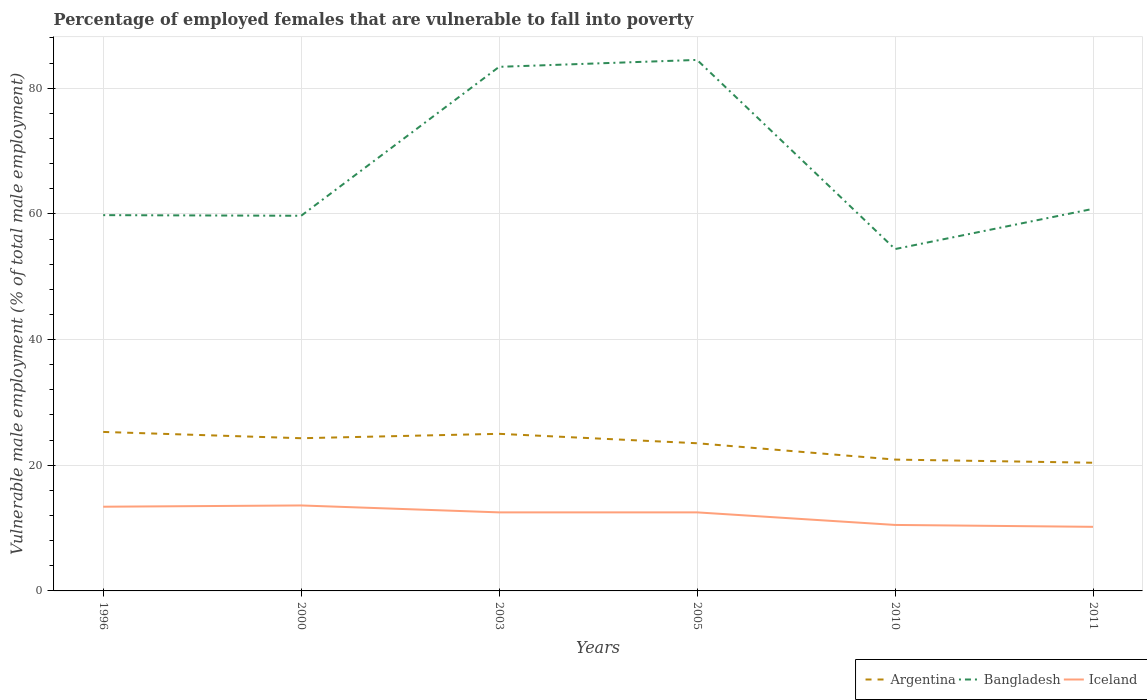Across all years, what is the maximum percentage of employed females who are vulnerable to fall into poverty in Bangladesh?
Your response must be concise. 54.4. In which year was the percentage of employed females who are vulnerable to fall into poverty in Argentina maximum?
Offer a terse response. 2011. What is the total percentage of employed females who are vulnerable to fall into poverty in Iceland in the graph?
Ensure brevity in your answer.  0.9. What is the difference between the highest and the second highest percentage of employed females who are vulnerable to fall into poverty in Iceland?
Give a very brief answer. 3.4. Is the percentage of employed females who are vulnerable to fall into poverty in Bangladesh strictly greater than the percentage of employed females who are vulnerable to fall into poverty in Iceland over the years?
Offer a terse response. No. How many lines are there?
Your answer should be compact. 3. What is the difference between two consecutive major ticks on the Y-axis?
Give a very brief answer. 20. Does the graph contain any zero values?
Give a very brief answer. No. Does the graph contain grids?
Give a very brief answer. Yes. Where does the legend appear in the graph?
Your answer should be very brief. Bottom right. What is the title of the graph?
Keep it short and to the point. Percentage of employed females that are vulnerable to fall into poverty. What is the label or title of the Y-axis?
Offer a terse response. Vulnerable male employment (% of total male employment). What is the Vulnerable male employment (% of total male employment) of Argentina in 1996?
Ensure brevity in your answer.  25.3. What is the Vulnerable male employment (% of total male employment) in Bangladesh in 1996?
Ensure brevity in your answer.  59.8. What is the Vulnerable male employment (% of total male employment) in Iceland in 1996?
Provide a short and direct response. 13.4. What is the Vulnerable male employment (% of total male employment) of Argentina in 2000?
Ensure brevity in your answer.  24.3. What is the Vulnerable male employment (% of total male employment) of Bangladesh in 2000?
Make the answer very short. 59.7. What is the Vulnerable male employment (% of total male employment) of Iceland in 2000?
Keep it short and to the point. 13.6. What is the Vulnerable male employment (% of total male employment) of Bangladesh in 2003?
Your answer should be compact. 83.4. What is the Vulnerable male employment (% of total male employment) of Argentina in 2005?
Make the answer very short. 23.5. What is the Vulnerable male employment (% of total male employment) of Bangladesh in 2005?
Offer a very short reply. 84.5. What is the Vulnerable male employment (% of total male employment) of Iceland in 2005?
Offer a terse response. 12.5. What is the Vulnerable male employment (% of total male employment) of Argentina in 2010?
Your response must be concise. 20.9. What is the Vulnerable male employment (% of total male employment) of Bangladesh in 2010?
Your response must be concise. 54.4. What is the Vulnerable male employment (% of total male employment) of Argentina in 2011?
Give a very brief answer. 20.4. What is the Vulnerable male employment (% of total male employment) in Bangladesh in 2011?
Provide a short and direct response. 60.8. What is the Vulnerable male employment (% of total male employment) of Iceland in 2011?
Your response must be concise. 10.2. Across all years, what is the maximum Vulnerable male employment (% of total male employment) in Argentina?
Keep it short and to the point. 25.3. Across all years, what is the maximum Vulnerable male employment (% of total male employment) of Bangladesh?
Your response must be concise. 84.5. Across all years, what is the maximum Vulnerable male employment (% of total male employment) of Iceland?
Ensure brevity in your answer.  13.6. Across all years, what is the minimum Vulnerable male employment (% of total male employment) in Argentina?
Your answer should be very brief. 20.4. Across all years, what is the minimum Vulnerable male employment (% of total male employment) in Bangladesh?
Ensure brevity in your answer.  54.4. Across all years, what is the minimum Vulnerable male employment (% of total male employment) in Iceland?
Your answer should be very brief. 10.2. What is the total Vulnerable male employment (% of total male employment) in Argentina in the graph?
Your answer should be very brief. 139.4. What is the total Vulnerable male employment (% of total male employment) of Bangladesh in the graph?
Give a very brief answer. 402.6. What is the total Vulnerable male employment (% of total male employment) in Iceland in the graph?
Make the answer very short. 72.7. What is the difference between the Vulnerable male employment (% of total male employment) in Argentina in 1996 and that in 2000?
Keep it short and to the point. 1. What is the difference between the Vulnerable male employment (% of total male employment) of Bangladesh in 1996 and that in 2000?
Ensure brevity in your answer.  0.1. What is the difference between the Vulnerable male employment (% of total male employment) of Argentina in 1996 and that in 2003?
Offer a terse response. 0.3. What is the difference between the Vulnerable male employment (% of total male employment) of Bangladesh in 1996 and that in 2003?
Provide a short and direct response. -23.6. What is the difference between the Vulnerable male employment (% of total male employment) in Bangladesh in 1996 and that in 2005?
Offer a very short reply. -24.7. What is the difference between the Vulnerable male employment (% of total male employment) in Argentina in 2000 and that in 2003?
Offer a terse response. -0.7. What is the difference between the Vulnerable male employment (% of total male employment) in Bangladesh in 2000 and that in 2003?
Your answer should be compact. -23.7. What is the difference between the Vulnerable male employment (% of total male employment) in Iceland in 2000 and that in 2003?
Make the answer very short. 1.1. What is the difference between the Vulnerable male employment (% of total male employment) in Bangladesh in 2000 and that in 2005?
Keep it short and to the point. -24.8. What is the difference between the Vulnerable male employment (% of total male employment) of Argentina in 2000 and that in 2010?
Offer a very short reply. 3.4. What is the difference between the Vulnerable male employment (% of total male employment) of Bangladesh in 2000 and that in 2010?
Your answer should be very brief. 5.3. What is the difference between the Vulnerable male employment (% of total male employment) of Argentina in 2000 and that in 2011?
Keep it short and to the point. 3.9. What is the difference between the Vulnerable male employment (% of total male employment) of Argentina in 2003 and that in 2005?
Your answer should be compact. 1.5. What is the difference between the Vulnerable male employment (% of total male employment) of Bangladesh in 2003 and that in 2005?
Your response must be concise. -1.1. What is the difference between the Vulnerable male employment (% of total male employment) of Iceland in 2003 and that in 2010?
Your answer should be compact. 2. What is the difference between the Vulnerable male employment (% of total male employment) in Bangladesh in 2003 and that in 2011?
Provide a short and direct response. 22.6. What is the difference between the Vulnerable male employment (% of total male employment) of Argentina in 2005 and that in 2010?
Offer a terse response. 2.6. What is the difference between the Vulnerable male employment (% of total male employment) of Bangladesh in 2005 and that in 2010?
Your response must be concise. 30.1. What is the difference between the Vulnerable male employment (% of total male employment) of Bangladesh in 2005 and that in 2011?
Provide a succinct answer. 23.7. What is the difference between the Vulnerable male employment (% of total male employment) in Iceland in 2005 and that in 2011?
Offer a terse response. 2.3. What is the difference between the Vulnerable male employment (% of total male employment) in Iceland in 2010 and that in 2011?
Provide a short and direct response. 0.3. What is the difference between the Vulnerable male employment (% of total male employment) in Argentina in 1996 and the Vulnerable male employment (% of total male employment) in Bangladesh in 2000?
Make the answer very short. -34.4. What is the difference between the Vulnerable male employment (% of total male employment) in Bangladesh in 1996 and the Vulnerable male employment (% of total male employment) in Iceland in 2000?
Offer a terse response. 46.2. What is the difference between the Vulnerable male employment (% of total male employment) in Argentina in 1996 and the Vulnerable male employment (% of total male employment) in Bangladesh in 2003?
Offer a very short reply. -58.1. What is the difference between the Vulnerable male employment (% of total male employment) of Argentina in 1996 and the Vulnerable male employment (% of total male employment) of Iceland in 2003?
Your response must be concise. 12.8. What is the difference between the Vulnerable male employment (% of total male employment) in Bangladesh in 1996 and the Vulnerable male employment (% of total male employment) in Iceland in 2003?
Your response must be concise. 47.3. What is the difference between the Vulnerable male employment (% of total male employment) in Argentina in 1996 and the Vulnerable male employment (% of total male employment) in Bangladesh in 2005?
Make the answer very short. -59.2. What is the difference between the Vulnerable male employment (% of total male employment) in Argentina in 1996 and the Vulnerable male employment (% of total male employment) in Iceland in 2005?
Offer a terse response. 12.8. What is the difference between the Vulnerable male employment (% of total male employment) in Bangladesh in 1996 and the Vulnerable male employment (% of total male employment) in Iceland in 2005?
Your response must be concise. 47.3. What is the difference between the Vulnerable male employment (% of total male employment) of Argentina in 1996 and the Vulnerable male employment (% of total male employment) of Bangladesh in 2010?
Offer a very short reply. -29.1. What is the difference between the Vulnerable male employment (% of total male employment) in Bangladesh in 1996 and the Vulnerable male employment (% of total male employment) in Iceland in 2010?
Provide a succinct answer. 49.3. What is the difference between the Vulnerable male employment (% of total male employment) in Argentina in 1996 and the Vulnerable male employment (% of total male employment) in Bangladesh in 2011?
Provide a succinct answer. -35.5. What is the difference between the Vulnerable male employment (% of total male employment) in Argentina in 1996 and the Vulnerable male employment (% of total male employment) in Iceland in 2011?
Make the answer very short. 15.1. What is the difference between the Vulnerable male employment (% of total male employment) in Bangladesh in 1996 and the Vulnerable male employment (% of total male employment) in Iceland in 2011?
Provide a short and direct response. 49.6. What is the difference between the Vulnerable male employment (% of total male employment) of Argentina in 2000 and the Vulnerable male employment (% of total male employment) of Bangladesh in 2003?
Give a very brief answer. -59.1. What is the difference between the Vulnerable male employment (% of total male employment) in Argentina in 2000 and the Vulnerable male employment (% of total male employment) in Iceland in 2003?
Provide a short and direct response. 11.8. What is the difference between the Vulnerable male employment (% of total male employment) in Bangladesh in 2000 and the Vulnerable male employment (% of total male employment) in Iceland in 2003?
Offer a terse response. 47.2. What is the difference between the Vulnerable male employment (% of total male employment) of Argentina in 2000 and the Vulnerable male employment (% of total male employment) of Bangladesh in 2005?
Give a very brief answer. -60.2. What is the difference between the Vulnerable male employment (% of total male employment) of Argentina in 2000 and the Vulnerable male employment (% of total male employment) of Iceland in 2005?
Provide a short and direct response. 11.8. What is the difference between the Vulnerable male employment (% of total male employment) in Bangladesh in 2000 and the Vulnerable male employment (% of total male employment) in Iceland in 2005?
Offer a very short reply. 47.2. What is the difference between the Vulnerable male employment (% of total male employment) in Argentina in 2000 and the Vulnerable male employment (% of total male employment) in Bangladesh in 2010?
Keep it short and to the point. -30.1. What is the difference between the Vulnerable male employment (% of total male employment) in Bangladesh in 2000 and the Vulnerable male employment (% of total male employment) in Iceland in 2010?
Your answer should be very brief. 49.2. What is the difference between the Vulnerable male employment (% of total male employment) in Argentina in 2000 and the Vulnerable male employment (% of total male employment) in Bangladesh in 2011?
Make the answer very short. -36.5. What is the difference between the Vulnerable male employment (% of total male employment) of Bangladesh in 2000 and the Vulnerable male employment (% of total male employment) of Iceland in 2011?
Give a very brief answer. 49.5. What is the difference between the Vulnerable male employment (% of total male employment) in Argentina in 2003 and the Vulnerable male employment (% of total male employment) in Bangladesh in 2005?
Ensure brevity in your answer.  -59.5. What is the difference between the Vulnerable male employment (% of total male employment) in Argentina in 2003 and the Vulnerable male employment (% of total male employment) in Iceland in 2005?
Give a very brief answer. 12.5. What is the difference between the Vulnerable male employment (% of total male employment) in Bangladesh in 2003 and the Vulnerable male employment (% of total male employment) in Iceland in 2005?
Provide a succinct answer. 70.9. What is the difference between the Vulnerable male employment (% of total male employment) of Argentina in 2003 and the Vulnerable male employment (% of total male employment) of Bangladesh in 2010?
Your response must be concise. -29.4. What is the difference between the Vulnerable male employment (% of total male employment) in Bangladesh in 2003 and the Vulnerable male employment (% of total male employment) in Iceland in 2010?
Your answer should be very brief. 72.9. What is the difference between the Vulnerable male employment (% of total male employment) in Argentina in 2003 and the Vulnerable male employment (% of total male employment) in Bangladesh in 2011?
Your answer should be very brief. -35.8. What is the difference between the Vulnerable male employment (% of total male employment) of Bangladesh in 2003 and the Vulnerable male employment (% of total male employment) of Iceland in 2011?
Offer a very short reply. 73.2. What is the difference between the Vulnerable male employment (% of total male employment) of Argentina in 2005 and the Vulnerable male employment (% of total male employment) of Bangladesh in 2010?
Your answer should be very brief. -30.9. What is the difference between the Vulnerable male employment (% of total male employment) of Argentina in 2005 and the Vulnerable male employment (% of total male employment) of Iceland in 2010?
Ensure brevity in your answer.  13. What is the difference between the Vulnerable male employment (% of total male employment) in Bangladesh in 2005 and the Vulnerable male employment (% of total male employment) in Iceland in 2010?
Keep it short and to the point. 74. What is the difference between the Vulnerable male employment (% of total male employment) of Argentina in 2005 and the Vulnerable male employment (% of total male employment) of Bangladesh in 2011?
Offer a very short reply. -37.3. What is the difference between the Vulnerable male employment (% of total male employment) in Bangladesh in 2005 and the Vulnerable male employment (% of total male employment) in Iceland in 2011?
Give a very brief answer. 74.3. What is the difference between the Vulnerable male employment (% of total male employment) in Argentina in 2010 and the Vulnerable male employment (% of total male employment) in Bangladesh in 2011?
Ensure brevity in your answer.  -39.9. What is the difference between the Vulnerable male employment (% of total male employment) in Bangladesh in 2010 and the Vulnerable male employment (% of total male employment) in Iceland in 2011?
Offer a very short reply. 44.2. What is the average Vulnerable male employment (% of total male employment) in Argentina per year?
Provide a succinct answer. 23.23. What is the average Vulnerable male employment (% of total male employment) in Bangladesh per year?
Ensure brevity in your answer.  67.1. What is the average Vulnerable male employment (% of total male employment) in Iceland per year?
Your response must be concise. 12.12. In the year 1996, what is the difference between the Vulnerable male employment (% of total male employment) in Argentina and Vulnerable male employment (% of total male employment) in Bangladesh?
Your answer should be compact. -34.5. In the year 1996, what is the difference between the Vulnerable male employment (% of total male employment) in Bangladesh and Vulnerable male employment (% of total male employment) in Iceland?
Offer a terse response. 46.4. In the year 2000, what is the difference between the Vulnerable male employment (% of total male employment) in Argentina and Vulnerable male employment (% of total male employment) in Bangladesh?
Keep it short and to the point. -35.4. In the year 2000, what is the difference between the Vulnerable male employment (% of total male employment) in Bangladesh and Vulnerable male employment (% of total male employment) in Iceland?
Your answer should be compact. 46.1. In the year 2003, what is the difference between the Vulnerable male employment (% of total male employment) of Argentina and Vulnerable male employment (% of total male employment) of Bangladesh?
Your answer should be very brief. -58.4. In the year 2003, what is the difference between the Vulnerable male employment (% of total male employment) in Argentina and Vulnerable male employment (% of total male employment) in Iceland?
Make the answer very short. 12.5. In the year 2003, what is the difference between the Vulnerable male employment (% of total male employment) of Bangladesh and Vulnerable male employment (% of total male employment) of Iceland?
Your answer should be compact. 70.9. In the year 2005, what is the difference between the Vulnerable male employment (% of total male employment) of Argentina and Vulnerable male employment (% of total male employment) of Bangladesh?
Your response must be concise. -61. In the year 2005, what is the difference between the Vulnerable male employment (% of total male employment) of Argentina and Vulnerable male employment (% of total male employment) of Iceland?
Your answer should be very brief. 11. In the year 2010, what is the difference between the Vulnerable male employment (% of total male employment) in Argentina and Vulnerable male employment (% of total male employment) in Bangladesh?
Keep it short and to the point. -33.5. In the year 2010, what is the difference between the Vulnerable male employment (% of total male employment) in Argentina and Vulnerable male employment (% of total male employment) in Iceland?
Your response must be concise. 10.4. In the year 2010, what is the difference between the Vulnerable male employment (% of total male employment) in Bangladesh and Vulnerable male employment (% of total male employment) in Iceland?
Give a very brief answer. 43.9. In the year 2011, what is the difference between the Vulnerable male employment (% of total male employment) of Argentina and Vulnerable male employment (% of total male employment) of Bangladesh?
Give a very brief answer. -40.4. In the year 2011, what is the difference between the Vulnerable male employment (% of total male employment) of Argentina and Vulnerable male employment (% of total male employment) of Iceland?
Your answer should be compact. 10.2. In the year 2011, what is the difference between the Vulnerable male employment (% of total male employment) in Bangladesh and Vulnerable male employment (% of total male employment) in Iceland?
Keep it short and to the point. 50.6. What is the ratio of the Vulnerable male employment (% of total male employment) in Argentina in 1996 to that in 2000?
Your answer should be very brief. 1.04. What is the ratio of the Vulnerable male employment (% of total male employment) of Bangladesh in 1996 to that in 2000?
Your answer should be compact. 1. What is the ratio of the Vulnerable male employment (% of total male employment) in Iceland in 1996 to that in 2000?
Provide a short and direct response. 0.99. What is the ratio of the Vulnerable male employment (% of total male employment) in Bangladesh in 1996 to that in 2003?
Provide a succinct answer. 0.72. What is the ratio of the Vulnerable male employment (% of total male employment) of Iceland in 1996 to that in 2003?
Keep it short and to the point. 1.07. What is the ratio of the Vulnerable male employment (% of total male employment) in Argentina in 1996 to that in 2005?
Offer a very short reply. 1.08. What is the ratio of the Vulnerable male employment (% of total male employment) of Bangladesh in 1996 to that in 2005?
Provide a short and direct response. 0.71. What is the ratio of the Vulnerable male employment (% of total male employment) of Iceland in 1996 to that in 2005?
Your answer should be compact. 1.07. What is the ratio of the Vulnerable male employment (% of total male employment) in Argentina in 1996 to that in 2010?
Make the answer very short. 1.21. What is the ratio of the Vulnerable male employment (% of total male employment) in Bangladesh in 1996 to that in 2010?
Your answer should be compact. 1.1. What is the ratio of the Vulnerable male employment (% of total male employment) of Iceland in 1996 to that in 2010?
Your answer should be compact. 1.28. What is the ratio of the Vulnerable male employment (% of total male employment) of Argentina in 1996 to that in 2011?
Ensure brevity in your answer.  1.24. What is the ratio of the Vulnerable male employment (% of total male employment) of Bangladesh in 1996 to that in 2011?
Offer a terse response. 0.98. What is the ratio of the Vulnerable male employment (% of total male employment) of Iceland in 1996 to that in 2011?
Provide a succinct answer. 1.31. What is the ratio of the Vulnerable male employment (% of total male employment) in Argentina in 2000 to that in 2003?
Offer a terse response. 0.97. What is the ratio of the Vulnerable male employment (% of total male employment) of Bangladesh in 2000 to that in 2003?
Provide a succinct answer. 0.72. What is the ratio of the Vulnerable male employment (% of total male employment) of Iceland in 2000 to that in 2003?
Offer a very short reply. 1.09. What is the ratio of the Vulnerable male employment (% of total male employment) of Argentina in 2000 to that in 2005?
Your answer should be very brief. 1.03. What is the ratio of the Vulnerable male employment (% of total male employment) in Bangladesh in 2000 to that in 2005?
Offer a terse response. 0.71. What is the ratio of the Vulnerable male employment (% of total male employment) of Iceland in 2000 to that in 2005?
Ensure brevity in your answer.  1.09. What is the ratio of the Vulnerable male employment (% of total male employment) in Argentina in 2000 to that in 2010?
Ensure brevity in your answer.  1.16. What is the ratio of the Vulnerable male employment (% of total male employment) in Bangladesh in 2000 to that in 2010?
Provide a short and direct response. 1.1. What is the ratio of the Vulnerable male employment (% of total male employment) in Iceland in 2000 to that in 2010?
Offer a terse response. 1.3. What is the ratio of the Vulnerable male employment (% of total male employment) of Argentina in 2000 to that in 2011?
Your answer should be very brief. 1.19. What is the ratio of the Vulnerable male employment (% of total male employment) in Bangladesh in 2000 to that in 2011?
Provide a short and direct response. 0.98. What is the ratio of the Vulnerable male employment (% of total male employment) of Iceland in 2000 to that in 2011?
Offer a terse response. 1.33. What is the ratio of the Vulnerable male employment (% of total male employment) in Argentina in 2003 to that in 2005?
Your answer should be compact. 1.06. What is the ratio of the Vulnerable male employment (% of total male employment) of Bangladesh in 2003 to that in 2005?
Provide a succinct answer. 0.99. What is the ratio of the Vulnerable male employment (% of total male employment) in Iceland in 2003 to that in 2005?
Your answer should be very brief. 1. What is the ratio of the Vulnerable male employment (% of total male employment) of Argentina in 2003 to that in 2010?
Your response must be concise. 1.2. What is the ratio of the Vulnerable male employment (% of total male employment) of Bangladesh in 2003 to that in 2010?
Ensure brevity in your answer.  1.53. What is the ratio of the Vulnerable male employment (% of total male employment) in Iceland in 2003 to that in 2010?
Make the answer very short. 1.19. What is the ratio of the Vulnerable male employment (% of total male employment) of Argentina in 2003 to that in 2011?
Offer a terse response. 1.23. What is the ratio of the Vulnerable male employment (% of total male employment) of Bangladesh in 2003 to that in 2011?
Give a very brief answer. 1.37. What is the ratio of the Vulnerable male employment (% of total male employment) in Iceland in 2003 to that in 2011?
Give a very brief answer. 1.23. What is the ratio of the Vulnerable male employment (% of total male employment) of Argentina in 2005 to that in 2010?
Keep it short and to the point. 1.12. What is the ratio of the Vulnerable male employment (% of total male employment) in Bangladesh in 2005 to that in 2010?
Give a very brief answer. 1.55. What is the ratio of the Vulnerable male employment (% of total male employment) of Iceland in 2005 to that in 2010?
Provide a succinct answer. 1.19. What is the ratio of the Vulnerable male employment (% of total male employment) in Argentina in 2005 to that in 2011?
Make the answer very short. 1.15. What is the ratio of the Vulnerable male employment (% of total male employment) of Bangladesh in 2005 to that in 2011?
Your response must be concise. 1.39. What is the ratio of the Vulnerable male employment (% of total male employment) of Iceland in 2005 to that in 2011?
Offer a very short reply. 1.23. What is the ratio of the Vulnerable male employment (% of total male employment) of Argentina in 2010 to that in 2011?
Your response must be concise. 1.02. What is the ratio of the Vulnerable male employment (% of total male employment) of Bangladesh in 2010 to that in 2011?
Your answer should be compact. 0.89. What is the ratio of the Vulnerable male employment (% of total male employment) in Iceland in 2010 to that in 2011?
Offer a terse response. 1.03. What is the difference between the highest and the second highest Vulnerable male employment (% of total male employment) of Bangladesh?
Provide a short and direct response. 1.1. What is the difference between the highest and the second highest Vulnerable male employment (% of total male employment) in Iceland?
Provide a succinct answer. 0.2. What is the difference between the highest and the lowest Vulnerable male employment (% of total male employment) in Bangladesh?
Give a very brief answer. 30.1. 